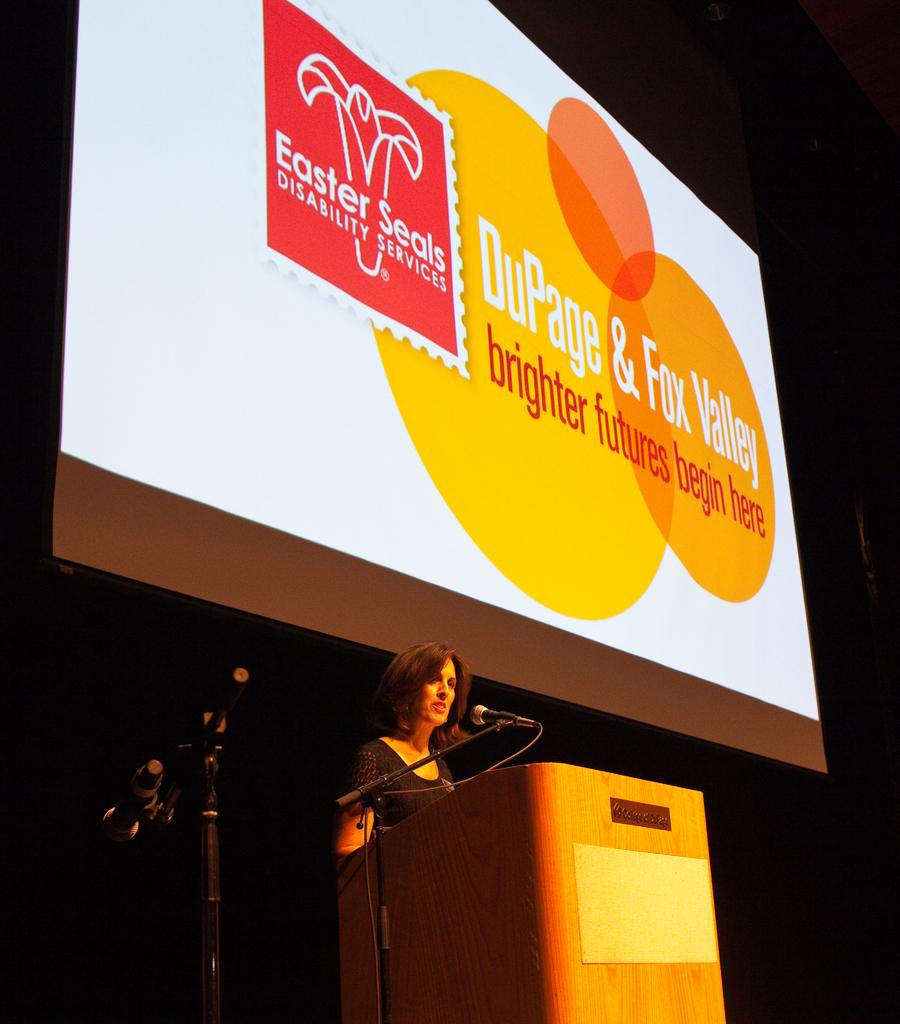What is the lady in the image doing? The lady is standing in the image. What is in front of the lady? There is a podium in front of the lady. What is used for amplifying sound near the podium? Microphones are placed on stands near the podium. What can be seen in the background of the image? There is a screen in the background of the image. How many gates are visible in the image? There are no gates present in the image. What type of pin is being used by the lady in the image? There is no pin visible in the image, and the lady is not performing any action that would require a pin. 